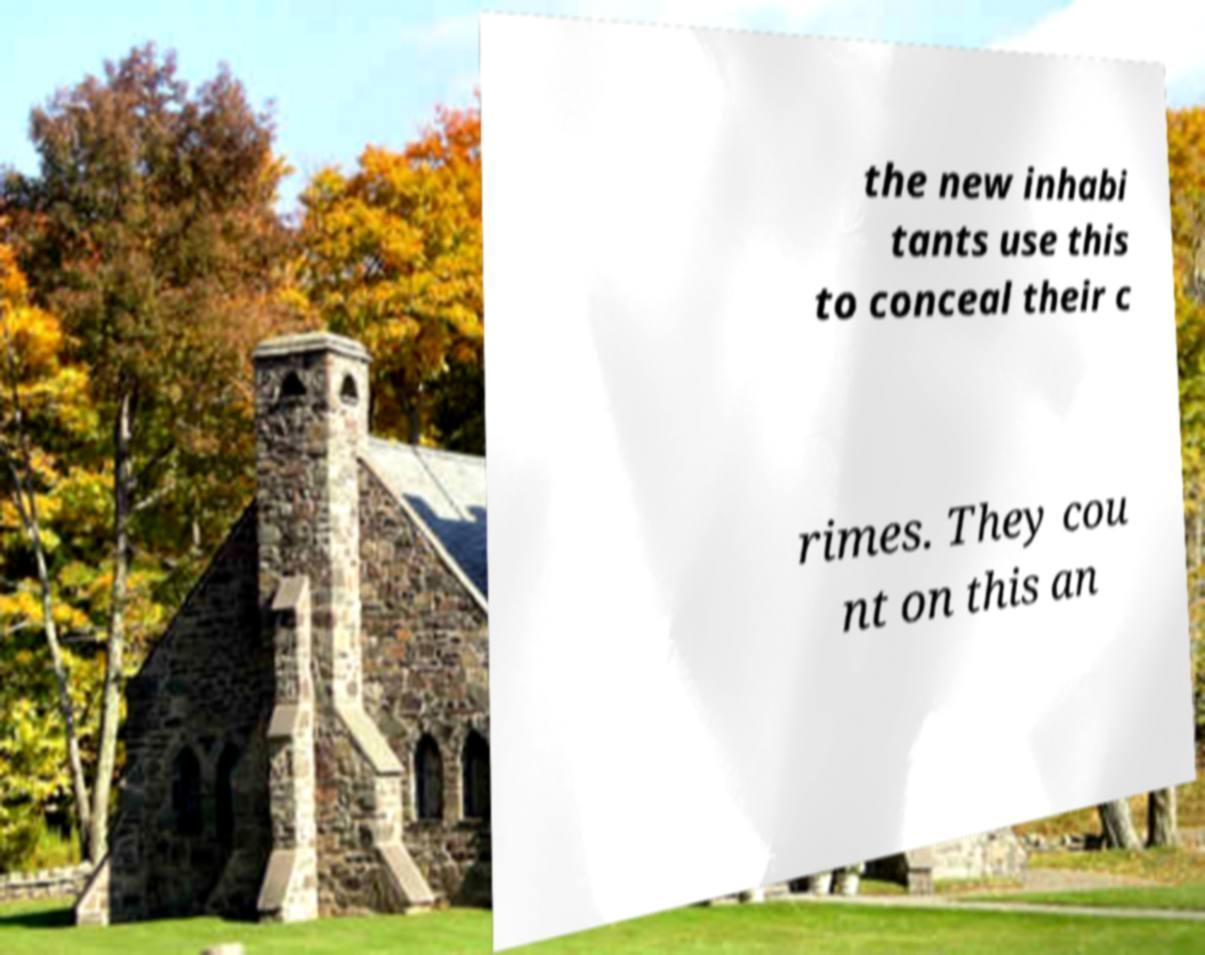Can you accurately transcribe the text from the provided image for me? the new inhabi tants use this to conceal their c rimes. They cou nt on this an 